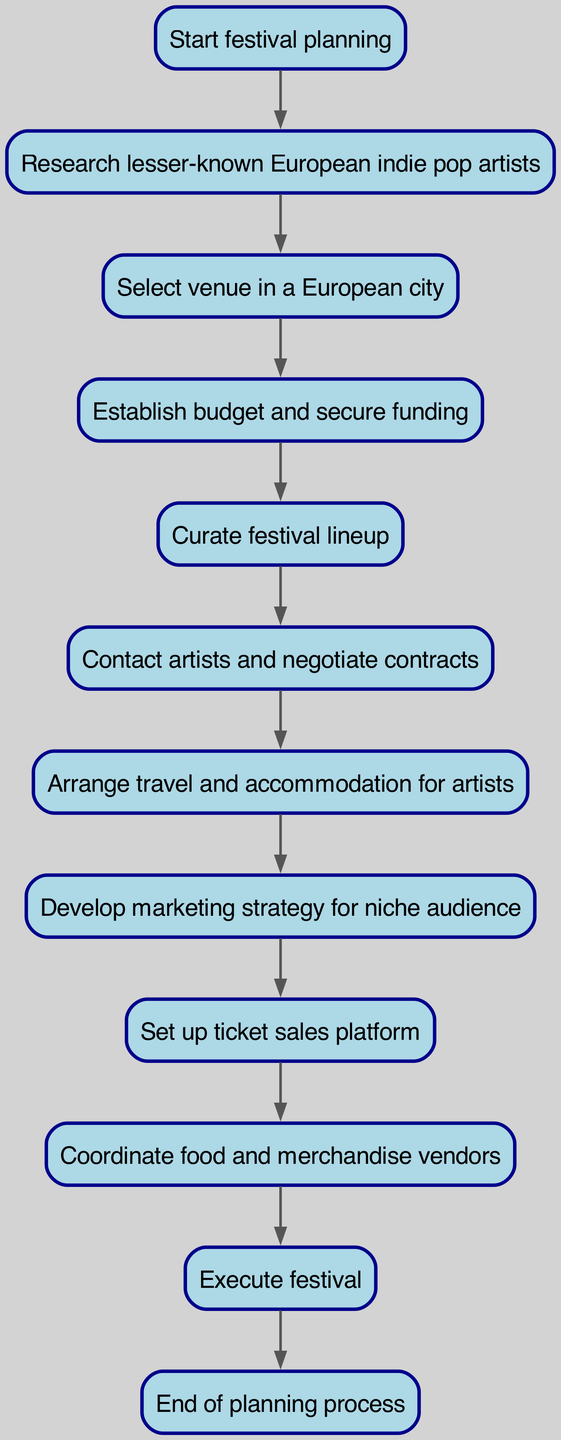what is the first step in the festival planning process? The first node in the diagram is labeled "Start festival planning," which indicates that this is the initial step of the entire process.
Answer: Start festival planning how many nodes are in the diagram? By counting each element in the provided data structure under "elements," we see there are twelve distinct nodes included.
Answer: 12 what comes after researching artists? The flowchart indicates that after "Research lesser-known European indie pop artists," the next step is to "Select venue in a European city."
Answer: Select venue in a European city which step involves artist contracts? In the flowchart, the step that deals with contracts among artists is labeled "Contact artists and negotiate contracts."
Answer: Contact artists and negotiate contracts what is the last step before executing the festival? Looking at the connections leading into the "Execute festival" node, the step immediately before it is "Coordinate food and merchandise vendors."
Answer: Coordinate food and merchandise vendors which step directly follows establishing a budget? In the flowchart, after "Establish budget and secure funding," the subsequent step is "Curate festival lineup."
Answer: Curate festival lineup how many connections are there in the diagram? By analyzing the "connections" section of the data, we find there are ten pairs listed that represent the directional flow from one node to another.
Answer: 10 what is the purpose of the 'promotion' step? The node labeled "Develop marketing strategy for niche audience" explains that the purpose of this step is to create a targeted marketing approach for audiences interested in indie pop music.
Answer: Develop marketing strategy for niche audience what comes after developing a marketing strategy? The flowchart reveals that the step that follows the marketing strategy is "Set up ticket sales platform."
Answer: Set up ticket sales platform 